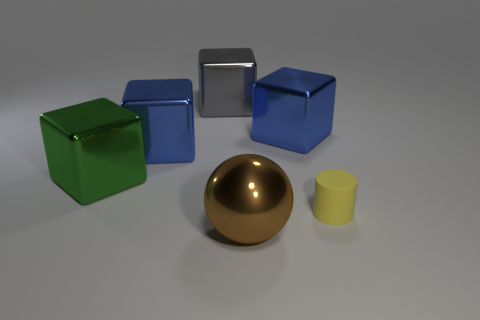Is there a tiny red thing that has the same shape as the green thing? no 